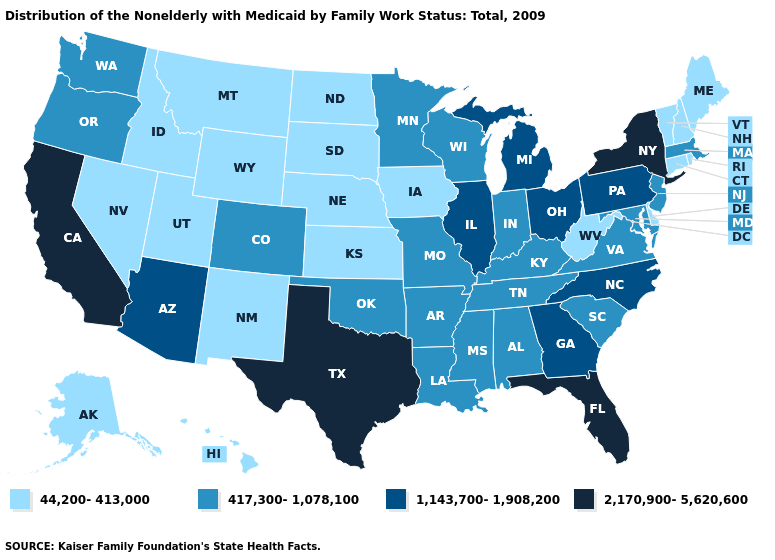Name the states that have a value in the range 1,143,700-1,908,200?
Short answer required. Arizona, Georgia, Illinois, Michigan, North Carolina, Ohio, Pennsylvania. Name the states that have a value in the range 44,200-413,000?
Give a very brief answer. Alaska, Connecticut, Delaware, Hawaii, Idaho, Iowa, Kansas, Maine, Montana, Nebraska, Nevada, New Hampshire, New Mexico, North Dakota, Rhode Island, South Dakota, Utah, Vermont, West Virginia, Wyoming. What is the value of Alaska?
Be succinct. 44,200-413,000. What is the lowest value in the USA?
Keep it brief. 44,200-413,000. What is the value of Rhode Island?
Be succinct. 44,200-413,000. Name the states that have a value in the range 44,200-413,000?
Give a very brief answer. Alaska, Connecticut, Delaware, Hawaii, Idaho, Iowa, Kansas, Maine, Montana, Nebraska, Nevada, New Hampshire, New Mexico, North Dakota, Rhode Island, South Dakota, Utah, Vermont, West Virginia, Wyoming. What is the value of Montana?
Give a very brief answer. 44,200-413,000. Among the states that border Tennessee , does Virginia have the highest value?
Short answer required. No. Which states have the lowest value in the USA?
Write a very short answer. Alaska, Connecticut, Delaware, Hawaii, Idaho, Iowa, Kansas, Maine, Montana, Nebraska, Nevada, New Hampshire, New Mexico, North Dakota, Rhode Island, South Dakota, Utah, Vermont, West Virginia, Wyoming. What is the value of Arkansas?
Concise answer only. 417,300-1,078,100. What is the value of Alaska?
Answer briefly. 44,200-413,000. What is the value of Maine?
Quick response, please. 44,200-413,000. Name the states that have a value in the range 44,200-413,000?
Answer briefly. Alaska, Connecticut, Delaware, Hawaii, Idaho, Iowa, Kansas, Maine, Montana, Nebraska, Nevada, New Hampshire, New Mexico, North Dakota, Rhode Island, South Dakota, Utah, Vermont, West Virginia, Wyoming. What is the value of New Jersey?
Quick response, please. 417,300-1,078,100. 